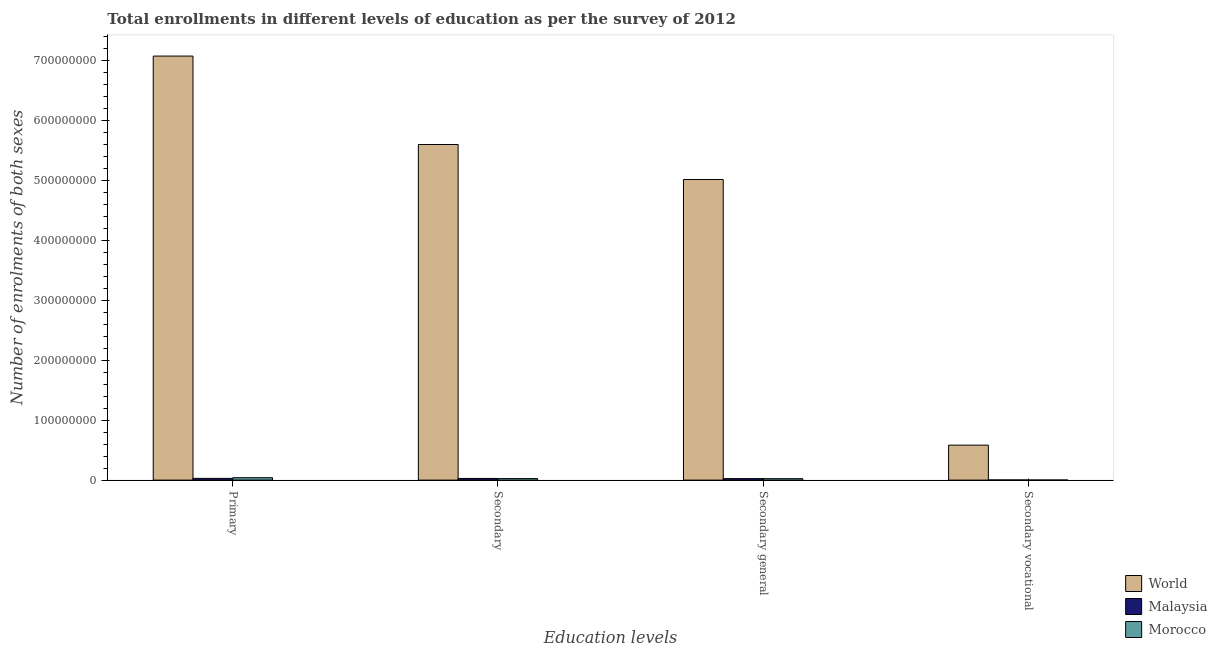How many groups of bars are there?
Provide a short and direct response. 4. Are the number of bars per tick equal to the number of legend labels?
Offer a very short reply. Yes. Are the number of bars on each tick of the X-axis equal?
Offer a very short reply. Yes. How many bars are there on the 3rd tick from the right?
Make the answer very short. 3. What is the label of the 1st group of bars from the left?
Give a very brief answer. Primary. What is the number of enrolments in primary education in Morocco?
Offer a terse response. 4.02e+06. Across all countries, what is the maximum number of enrolments in secondary education?
Provide a short and direct response. 5.60e+08. Across all countries, what is the minimum number of enrolments in secondary education?
Provide a succinct answer. 2.55e+06. In which country was the number of enrolments in secondary vocational education maximum?
Offer a terse response. World. In which country was the number of enrolments in secondary vocational education minimum?
Provide a short and direct response. Morocco. What is the total number of enrolments in secondary education in the graph?
Offer a terse response. 5.66e+08. What is the difference between the number of enrolments in secondary general education in Morocco and that in World?
Offer a terse response. -4.99e+08. What is the difference between the number of enrolments in secondary education in Morocco and the number of enrolments in secondary general education in Malaysia?
Your answer should be compact. 5.72e+04. What is the average number of enrolments in secondary education per country?
Provide a succinct answer. 1.89e+08. What is the difference between the number of enrolments in primary education and number of enrolments in secondary general education in World?
Your answer should be very brief. 2.06e+08. In how many countries, is the number of enrolments in secondary education greater than 640000000 ?
Provide a succinct answer. 0. What is the ratio of the number of enrolments in secondary vocational education in World to that in Morocco?
Provide a succinct answer. 375.79. Is the number of enrolments in secondary general education in Morocco less than that in World?
Provide a short and direct response. Yes. Is the difference between the number of enrolments in secondary education in Malaysia and Morocco greater than the difference between the number of enrolments in secondary vocational education in Malaysia and Morocco?
Keep it short and to the point. Yes. What is the difference between the highest and the second highest number of enrolments in secondary education?
Your response must be concise. 5.57e+08. What is the difference between the highest and the lowest number of enrolments in secondary general education?
Offer a very short reply. 4.99e+08. What does the 3rd bar from the left in Secondary general represents?
Your answer should be compact. Morocco. What does the 1st bar from the right in Secondary vocational represents?
Your response must be concise. Morocco. Is it the case that in every country, the sum of the number of enrolments in primary education and number of enrolments in secondary education is greater than the number of enrolments in secondary general education?
Keep it short and to the point. Yes. How many bars are there?
Provide a short and direct response. 12. How many countries are there in the graph?
Your answer should be compact. 3. Does the graph contain any zero values?
Keep it short and to the point. No. Does the graph contain grids?
Your response must be concise. No. How many legend labels are there?
Provide a succinct answer. 3. How are the legend labels stacked?
Your response must be concise. Vertical. What is the title of the graph?
Give a very brief answer. Total enrollments in different levels of education as per the survey of 2012. Does "Central Europe" appear as one of the legend labels in the graph?
Your answer should be compact. No. What is the label or title of the X-axis?
Keep it short and to the point. Education levels. What is the label or title of the Y-axis?
Your answer should be very brief. Number of enrolments of both sexes. What is the Number of enrolments of both sexes of World in Primary?
Provide a succinct answer. 7.08e+08. What is the Number of enrolments of both sexes of Malaysia in Primary?
Provide a succinct answer. 2.89e+06. What is the Number of enrolments of both sexes of Morocco in Primary?
Your response must be concise. 4.02e+06. What is the Number of enrolments of both sexes of World in Secondary?
Ensure brevity in your answer.  5.60e+08. What is the Number of enrolments of both sexes of Malaysia in Secondary?
Keep it short and to the point. 2.76e+06. What is the Number of enrolments of both sexes of Morocco in Secondary?
Your answer should be very brief. 2.55e+06. What is the Number of enrolments of both sexes of World in Secondary general?
Offer a very short reply. 5.02e+08. What is the Number of enrolments of both sexes in Malaysia in Secondary general?
Ensure brevity in your answer.  2.50e+06. What is the Number of enrolments of both sexes in Morocco in Secondary general?
Offer a terse response. 2.40e+06. What is the Number of enrolments of both sexes of World in Secondary vocational?
Your answer should be compact. 5.84e+07. What is the Number of enrolments of both sexes of Malaysia in Secondary vocational?
Your answer should be compact. 2.61e+05. What is the Number of enrolments of both sexes of Morocco in Secondary vocational?
Keep it short and to the point. 1.55e+05. Across all Education levels, what is the maximum Number of enrolments of both sexes in World?
Keep it short and to the point. 7.08e+08. Across all Education levels, what is the maximum Number of enrolments of both sexes in Malaysia?
Your answer should be compact. 2.89e+06. Across all Education levels, what is the maximum Number of enrolments of both sexes in Morocco?
Ensure brevity in your answer.  4.02e+06. Across all Education levels, what is the minimum Number of enrolments of both sexes of World?
Offer a very short reply. 5.84e+07. Across all Education levels, what is the minimum Number of enrolments of both sexes of Malaysia?
Your response must be concise. 2.61e+05. Across all Education levels, what is the minimum Number of enrolments of both sexes in Morocco?
Ensure brevity in your answer.  1.55e+05. What is the total Number of enrolments of both sexes in World in the graph?
Your answer should be compact. 1.83e+09. What is the total Number of enrolments of both sexes of Malaysia in the graph?
Keep it short and to the point. 8.40e+06. What is the total Number of enrolments of both sexes of Morocco in the graph?
Give a very brief answer. 9.13e+06. What is the difference between the Number of enrolments of both sexes of World in Primary and that in Secondary?
Provide a short and direct response. 1.48e+08. What is the difference between the Number of enrolments of both sexes in Malaysia in Primary and that in Secondary?
Ensure brevity in your answer.  1.31e+05. What is the difference between the Number of enrolments of both sexes in Morocco in Primary and that in Secondary?
Make the answer very short. 1.46e+06. What is the difference between the Number of enrolments of both sexes of World in Primary and that in Secondary general?
Offer a very short reply. 2.06e+08. What is the difference between the Number of enrolments of both sexes in Malaysia in Primary and that in Secondary general?
Your answer should be compact. 3.91e+05. What is the difference between the Number of enrolments of both sexes of Morocco in Primary and that in Secondary general?
Provide a short and direct response. 1.62e+06. What is the difference between the Number of enrolments of both sexes in World in Primary and that in Secondary vocational?
Keep it short and to the point. 6.49e+08. What is the difference between the Number of enrolments of both sexes of Malaysia in Primary and that in Secondary vocational?
Your response must be concise. 2.63e+06. What is the difference between the Number of enrolments of both sexes of Morocco in Primary and that in Secondary vocational?
Give a very brief answer. 3.86e+06. What is the difference between the Number of enrolments of both sexes of World in Secondary and that in Secondary general?
Provide a succinct answer. 5.84e+07. What is the difference between the Number of enrolments of both sexes of Malaysia in Secondary and that in Secondary general?
Ensure brevity in your answer.  2.61e+05. What is the difference between the Number of enrolments of both sexes of Morocco in Secondary and that in Secondary general?
Your answer should be compact. 1.55e+05. What is the difference between the Number of enrolments of both sexes in World in Secondary and that in Secondary vocational?
Your answer should be compact. 5.02e+08. What is the difference between the Number of enrolments of both sexes of Malaysia in Secondary and that in Secondary vocational?
Make the answer very short. 2.50e+06. What is the difference between the Number of enrolments of both sexes of Morocco in Secondary and that in Secondary vocational?
Keep it short and to the point. 2.40e+06. What is the difference between the Number of enrolments of both sexes in World in Secondary general and that in Secondary vocational?
Your response must be concise. 4.43e+08. What is the difference between the Number of enrolments of both sexes of Malaysia in Secondary general and that in Secondary vocational?
Your answer should be very brief. 2.24e+06. What is the difference between the Number of enrolments of both sexes of Morocco in Secondary general and that in Secondary vocational?
Your response must be concise. 2.24e+06. What is the difference between the Number of enrolments of both sexes of World in Primary and the Number of enrolments of both sexes of Malaysia in Secondary?
Provide a succinct answer. 7.05e+08. What is the difference between the Number of enrolments of both sexes in World in Primary and the Number of enrolments of both sexes in Morocco in Secondary?
Give a very brief answer. 7.05e+08. What is the difference between the Number of enrolments of both sexes of Malaysia in Primary and the Number of enrolments of both sexes of Morocco in Secondary?
Make the answer very short. 3.34e+05. What is the difference between the Number of enrolments of both sexes of World in Primary and the Number of enrolments of both sexes of Malaysia in Secondary general?
Your answer should be very brief. 7.05e+08. What is the difference between the Number of enrolments of both sexes of World in Primary and the Number of enrolments of both sexes of Morocco in Secondary general?
Give a very brief answer. 7.05e+08. What is the difference between the Number of enrolments of both sexes in Malaysia in Primary and the Number of enrolments of both sexes in Morocco in Secondary general?
Your answer should be very brief. 4.89e+05. What is the difference between the Number of enrolments of both sexes in World in Primary and the Number of enrolments of both sexes in Malaysia in Secondary vocational?
Offer a very short reply. 7.08e+08. What is the difference between the Number of enrolments of both sexes of World in Primary and the Number of enrolments of both sexes of Morocco in Secondary vocational?
Provide a succinct answer. 7.08e+08. What is the difference between the Number of enrolments of both sexes of Malaysia in Primary and the Number of enrolments of both sexes of Morocco in Secondary vocational?
Keep it short and to the point. 2.73e+06. What is the difference between the Number of enrolments of both sexes in World in Secondary and the Number of enrolments of both sexes in Malaysia in Secondary general?
Your response must be concise. 5.58e+08. What is the difference between the Number of enrolments of both sexes in World in Secondary and the Number of enrolments of both sexes in Morocco in Secondary general?
Your answer should be compact. 5.58e+08. What is the difference between the Number of enrolments of both sexes of Malaysia in Secondary and the Number of enrolments of both sexes of Morocco in Secondary general?
Provide a succinct answer. 3.59e+05. What is the difference between the Number of enrolments of both sexes in World in Secondary and the Number of enrolments of both sexes in Malaysia in Secondary vocational?
Provide a succinct answer. 5.60e+08. What is the difference between the Number of enrolments of both sexes in World in Secondary and the Number of enrolments of both sexes in Morocco in Secondary vocational?
Ensure brevity in your answer.  5.60e+08. What is the difference between the Number of enrolments of both sexes of Malaysia in Secondary and the Number of enrolments of both sexes of Morocco in Secondary vocational?
Your answer should be very brief. 2.60e+06. What is the difference between the Number of enrolments of both sexes in World in Secondary general and the Number of enrolments of both sexes in Malaysia in Secondary vocational?
Offer a very short reply. 5.02e+08. What is the difference between the Number of enrolments of both sexes in World in Secondary general and the Number of enrolments of both sexes in Morocco in Secondary vocational?
Offer a very short reply. 5.02e+08. What is the difference between the Number of enrolments of both sexes in Malaysia in Secondary general and the Number of enrolments of both sexes in Morocco in Secondary vocational?
Provide a short and direct response. 2.34e+06. What is the average Number of enrolments of both sexes in World per Education levels?
Your answer should be very brief. 4.57e+08. What is the average Number of enrolments of both sexes in Malaysia per Education levels?
Your answer should be very brief. 2.10e+06. What is the average Number of enrolments of both sexes in Morocco per Education levels?
Offer a very short reply. 2.28e+06. What is the difference between the Number of enrolments of both sexes of World and Number of enrolments of both sexes of Malaysia in Primary?
Your answer should be compact. 7.05e+08. What is the difference between the Number of enrolments of both sexes in World and Number of enrolments of both sexes in Morocco in Primary?
Your answer should be very brief. 7.04e+08. What is the difference between the Number of enrolments of both sexes in Malaysia and Number of enrolments of both sexes in Morocco in Primary?
Offer a very short reply. -1.13e+06. What is the difference between the Number of enrolments of both sexes of World and Number of enrolments of both sexes of Malaysia in Secondary?
Your answer should be compact. 5.57e+08. What is the difference between the Number of enrolments of both sexes of World and Number of enrolments of both sexes of Morocco in Secondary?
Provide a short and direct response. 5.58e+08. What is the difference between the Number of enrolments of both sexes in Malaysia and Number of enrolments of both sexes in Morocco in Secondary?
Offer a terse response. 2.03e+05. What is the difference between the Number of enrolments of both sexes of World and Number of enrolments of both sexes of Malaysia in Secondary general?
Give a very brief answer. 4.99e+08. What is the difference between the Number of enrolments of both sexes of World and Number of enrolments of both sexes of Morocco in Secondary general?
Provide a short and direct response. 4.99e+08. What is the difference between the Number of enrolments of both sexes of Malaysia and Number of enrolments of both sexes of Morocco in Secondary general?
Make the answer very short. 9.82e+04. What is the difference between the Number of enrolments of both sexes in World and Number of enrolments of both sexes in Malaysia in Secondary vocational?
Keep it short and to the point. 5.81e+07. What is the difference between the Number of enrolments of both sexes of World and Number of enrolments of both sexes of Morocco in Secondary vocational?
Offer a very short reply. 5.82e+07. What is the difference between the Number of enrolments of both sexes of Malaysia and Number of enrolments of both sexes of Morocco in Secondary vocational?
Your response must be concise. 1.05e+05. What is the ratio of the Number of enrolments of both sexes in World in Primary to that in Secondary?
Ensure brevity in your answer.  1.26. What is the ratio of the Number of enrolments of both sexes in Malaysia in Primary to that in Secondary?
Offer a terse response. 1.05. What is the ratio of the Number of enrolments of both sexes in Morocco in Primary to that in Secondary?
Your answer should be compact. 1.57. What is the ratio of the Number of enrolments of both sexes of World in Primary to that in Secondary general?
Give a very brief answer. 1.41. What is the ratio of the Number of enrolments of both sexes in Malaysia in Primary to that in Secondary general?
Your answer should be compact. 1.16. What is the ratio of the Number of enrolments of both sexes in Morocco in Primary to that in Secondary general?
Ensure brevity in your answer.  1.67. What is the ratio of the Number of enrolments of both sexes in World in Primary to that in Secondary vocational?
Ensure brevity in your answer.  12.12. What is the ratio of the Number of enrolments of both sexes of Malaysia in Primary to that in Secondary vocational?
Offer a very short reply. 11.08. What is the ratio of the Number of enrolments of both sexes in Morocco in Primary to that in Secondary vocational?
Your response must be concise. 25.85. What is the ratio of the Number of enrolments of both sexes of World in Secondary to that in Secondary general?
Your response must be concise. 1.12. What is the ratio of the Number of enrolments of both sexes in Malaysia in Secondary to that in Secondary general?
Your answer should be compact. 1.1. What is the ratio of the Number of enrolments of both sexes in Morocco in Secondary to that in Secondary general?
Give a very brief answer. 1.06. What is the ratio of the Number of enrolments of both sexes of World in Secondary to that in Secondary vocational?
Make the answer very short. 9.59. What is the ratio of the Number of enrolments of both sexes of Malaysia in Secondary to that in Secondary vocational?
Your answer should be compact. 10.58. What is the ratio of the Number of enrolments of both sexes in Morocco in Secondary to that in Secondary vocational?
Provide a short and direct response. 16.43. What is the ratio of the Number of enrolments of both sexes of World in Secondary general to that in Secondary vocational?
Make the answer very short. 8.59. What is the ratio of the Number of enrolments of both sexes in Malaysia in Secondary general to that in Secondary vocational?
Your answer should be very brief. 9.58. What is the ratio of the Number of enrolments of both sexes of Morocco in Secondary general to that in Secondary vocational?
Keep it short and to the point. 15.43. What is the difference between the highest and the second highest Number of enrolments of both sexes in World?
Keep it short and to the point. 1.48e+08. What is the difference between the highest and the second highest Number of enrolments of both sexes of Malaysia?
Give a very brief answer. 1.31e+05. What is the difference between the highest and the second highest Number of enrolments of both sexes of Morocco?
Give a very brief answer. 1.46e+06. What is the difference between the highest and the lowest Number of enrolments of both sexes in World?
Make the answer very short. 6.49e+08. What is the difference between the highest and the lowest Number of enrolments of both sexes in Malaysia?
Keep it short and to the point. 2.63e+06. What is the difference between the highest and the lowest Number of enrolments of both sexes of Morocco?
Provide a short and direct response. 3.86e+06. 